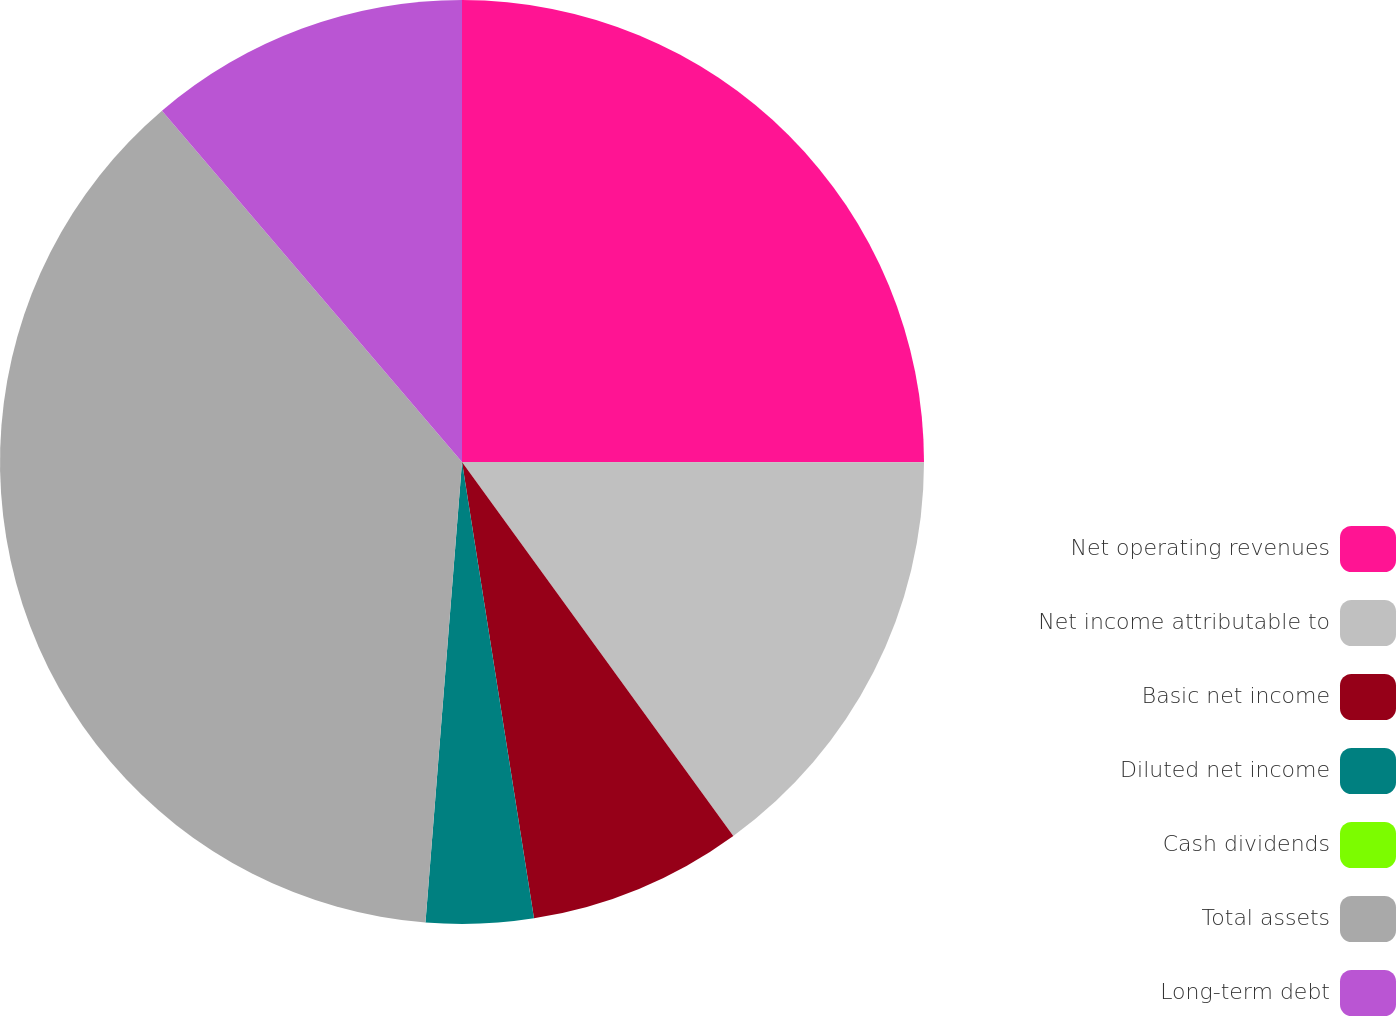<chart> <loc_0><loc_0><loc_500><loc_500><pie_chart><fcel>Net operating revenues<fcel>Net income attributable to<fcel>Basic net income<fcel>Diluted net income<fcel>Cash dividends<fcel>Total assets<fcel>Long-term debt<nl><fcel>25.01%<fcel>15.0%<fcel>7.5%<fcel>3.75%<fcel>0.0%<fcel>37.49%<fcel>11.25%<nl></chart> 